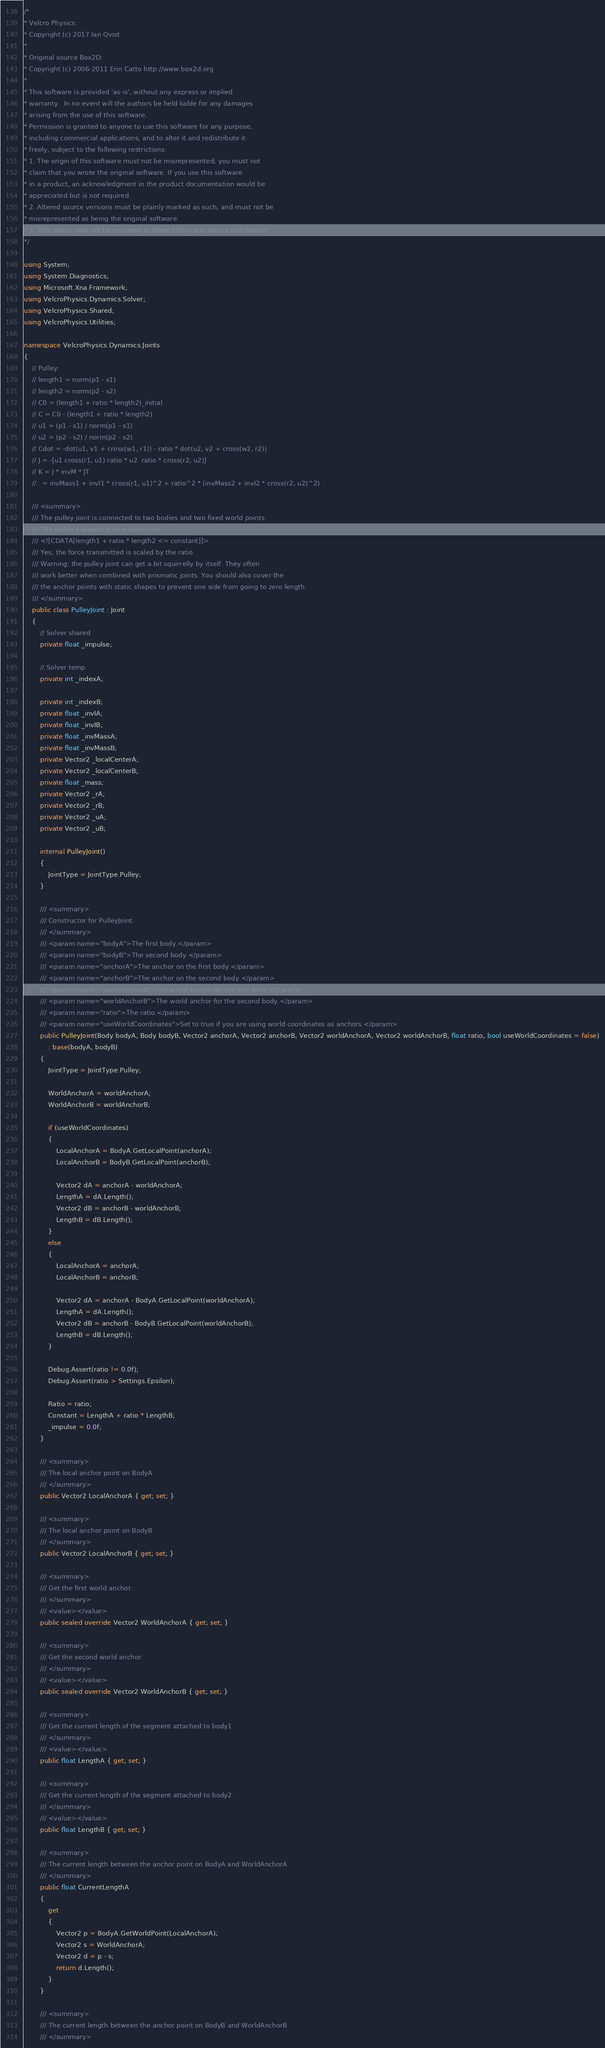<code> <loc_0><loc_0><loc_500><loc_500><_C#_>/*
* Velcro Physics:
* Copyright (c) 2017 Ian Qvist
* 
* Original source Box2D:
* Copyright (c) 2006-2011 Erin Catto http://www.box2d.org 
* 
* This software is provided 'as-is', without any express or implied 
* warranty.  In no event will the authors be held liable for any damages 
* arising from the use of this software. 
* Permission is granted to anyone to use this software for any purpose, 
* including commercial applications, and to alter it and redistribute it 
* freely, subject to the following restrictions: 
* 1. The origin of this software must not be misrepresented; you must not 
* claim that you wrote the original software. If you use this software 
* in a product, an acknowledgment in the product documentation would be 
* appreciated but is not required. 
* 2. Altered source versions must be plainly marked as such, and must not be 
* misrepresented as being the original software. 
* 3. This notice may not be removed or altered from any source distribution. 
*/

using System;
using System.Diagnostics;
using Microsoft.Xna.Framework;
using VelcroPhysics.Dynamics.Solver;
using VelcroPhysics.Shared;
using VelcroPhysics.Utilities;

namespace VelcroPhysics.Dynamics.Joints
{
    // Pulley:
    // length1 = norm(p1 - s1)
    // length2 = norm(p2 - s2)
    // C0 = (length1 + ratio * length2)_initial
    // C = C0 - (length1 + ratio * length2)
    // u1 = (p1 - s1) / norm(p1 - s1)
    // u2 = (p2 - s2) / norm(p2 - s2)
    // Cdot = -dot(u1, v1 + cross(w1, r1)) - ratio * dot(u2, v2 + cross(w2, r2))
    // J = -[u1 cross(r1, u1) ratio * u2  ratio * cross(r2, u2)]
    // K = J * invM * JT
    //   = invMass1 + invI1 * cross(r1, u1)^2 + ratio^2 * (invMass2 + invI2 * cross(r2, u2)^2)

    /// <summary>
    /// The pulley joint is connected to two bodies and two fixed world points.
    /// The pulley supports a ratio such that:
    /// <![CDATA[length1 + ratio * length2 <= constant]]>
    /// Yes, the force transmitted is scaled by the ratio.
    /// Warning: the pulley joint can get a bit squirrelly by itself. They often
    /// work better when combined with prismatic joints. You should also cover the
    /// the anchor points with static shapes to prevent one side from going to zero length.
    /// </summary>
    public class PulleyJoint : Joint
    {
        // Solver shared
        private float _impulse;

        // Solver temp
        private int _indexA;

        private int _indexB;
        private float _invIA;
        private float _invIB;
        private float _invMassA;
        private float _invMassB;
        private Vector2 _localCenterA;
        private Vector2 _localCenterB;
        private float _mass;
        private Vector2 _rA;
        private Vector2 _rB;
        private Vector2 _uA;
        private Vector2 _uB;

        internal PulleyJoint()
        {
            JointType = JointType.Pulley;
        }

        /// <summary>
        /// Constructor for PulleyJoint.
        /// </summary>
        /// <param name="bodyA">The first body.</param>
        /// <param name="bodyB">The second body.</param>
        /// <param name="anchorA">The anchor on the first body.</param>
        /// <param name="anchorB">The anchor on the second body.</param>
        /// <param name="worldAnchorA">The world anchor for the first body.</param>
        /// <param name="worldAnchorB">The world anchor for the second body.</param>
        /// <param name="ratio">The ratio.</param>
        /// <param name="useWorldCoordinates">Set to true if you are using world coordinates as anchors.</param>
        public PulleyJoint(Body bodyA, Body bodyB, Vector2 anchorA, Vector2 anchorB, Vector2 worldAnchorA, Vector2 worldAnchorB, float ratio, bool useWorldCoordinates = false)
            : base(bodyA, bodyB)
        {
            JointType = JointType.Pulley;

            WorldAnchorA = worldAnchorA;
            WorldAnchorB = worldAnchorB;

            if (useWorldCoordinates)
            {
                LocalAnchorA = BodyA.GetLocalPoint(anchorA);
                LocalAnchorB = BodyB.GetLocalPoint(anchorB);

                Vector2 dA = anchorA - worldAnchorA;
                LengthA = dA.Length();
                Vector2 dB = anchorB - worldAnchorB;
                LengthB = dB.Length();
            }
            else
            {
                LocalAnchorA = anchorA;
                LocalAnchorB = anchorB;

                Vector2 dA = anchorA - BodyA.GetLocalPoint(worldAnchorA);
                LengthA = dA.Length();
                Vector2 dB = anchorB - BodyB.GetLocalPoint(worldAnchorB);
                LengthB = dB.Length();
            }

            Debug.Assert(ratio != 0.0f);
            Debug.Assert(ratio > Settings.Epsilon);

            Ratio = ratio;
            Constant = LengthA + ratio * LengthB;
            _impulse = 0.0f;
        }

        /// <summary>
        /// The local anchor point on BodyA
        /// </summary>
        public Vector2 LocalAnchorA { get; set; }

        /// <summary>
        /// The local anchor point on BodyB
        /// </summary>
        public Vector2 LocalAnchorB { get; set; }

        /// <summary>
        /// Get the first world anchor.
        /// </summary>
        /// <value></value>
        public sealed override Vector2 WorldAnchorA { get; set; }

        /// <summary>
        /// Get the second world anchor.
        /// </summary>
        /// <value></value>
        public sealed override Vector2 WorldAnchorB { get; set; }

        /// <summary>
        /// Get the current length of the segment attached to body1.
        /// </summary>
        /// <value></value>
        public float LengthA { get; set; }

        /// <summary>
        /// Get the current length of the segment attached to body2.
        /// </summary>
        /// <value></value>
        public float LengthB { get; set; }

        /// <summary>
        /// The current length between the anchor point on BodyA and WorldAnchorA
        /// </summary>
        public float CurrentLengthA
        {
            get
            {
                Vector2 p = BodyA.GetWorldPoint(LocalAnchorA);
                Vector2 s = WorldAnchorA;
                Vector2 d = p - s;
                return d.Length();
            }
        }

        /// <summary>
        /// The current length between the anchor point on BodyB and WorldAnchorB
        /// </summary></code> 